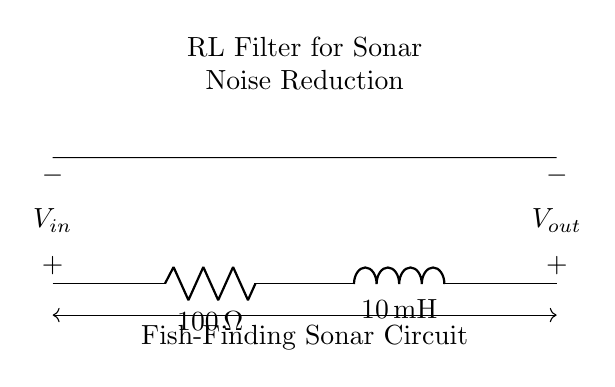What is the resistance value in the circuit? The resistance value is indicated by the label on the resistor in the circuit diagram, which shows as one hundred ohms.
Answer: one hundred ohms What type of inductor is used in this circuit? The circuit diagram specifies the inductor with a label detailing its value. It shows a ten milli-henry inductor, indicating the type of inductor in the circuit.
Answer: ten milli-henry What is the purpose of the RL filter in this circuit? The circuit is labeled as an RL filter designed for noise reduction. The combination of a resistor and an inductor helps filter out unwanted frequencies, making it suitable for sonar equipment.
Answer: noise reduction What are the input and output voltages represented in this circuit? The input voltage is represented at the start of the circuit labeled as V in, and the output voltage appears at the end of the circuit as V out.
Answer: V in and V out How does the resistor affect the overall circuit behavior? The resistor in this RL circuit limits the current flow and influences the time constant of the circuit. It works together with the inductor to determine how quickly the circuit responds to changes, therefore aiding in noise reduction.
Answer: limits current flow What happens to the frequency response of the filter as the inductor value increases? An increase in the inductor value typically lowers the cutoff frequency of the RL filter, thus improving its ability to block high-frequency noise and allowing lower frequencies to pass through more effectively.
Answer: lowers the cutoff frequency How would you calculate the time constant of this RL filter? The time constant for an RL circuit is calculated using the formula tau equals L divided by R, where L is the inductance in henries and R is the resistance in ohms. In this circuit, it would be calculated as ten milli-henry divided by one hundred ohms.
Answer: tau equals 0.1 seconds 